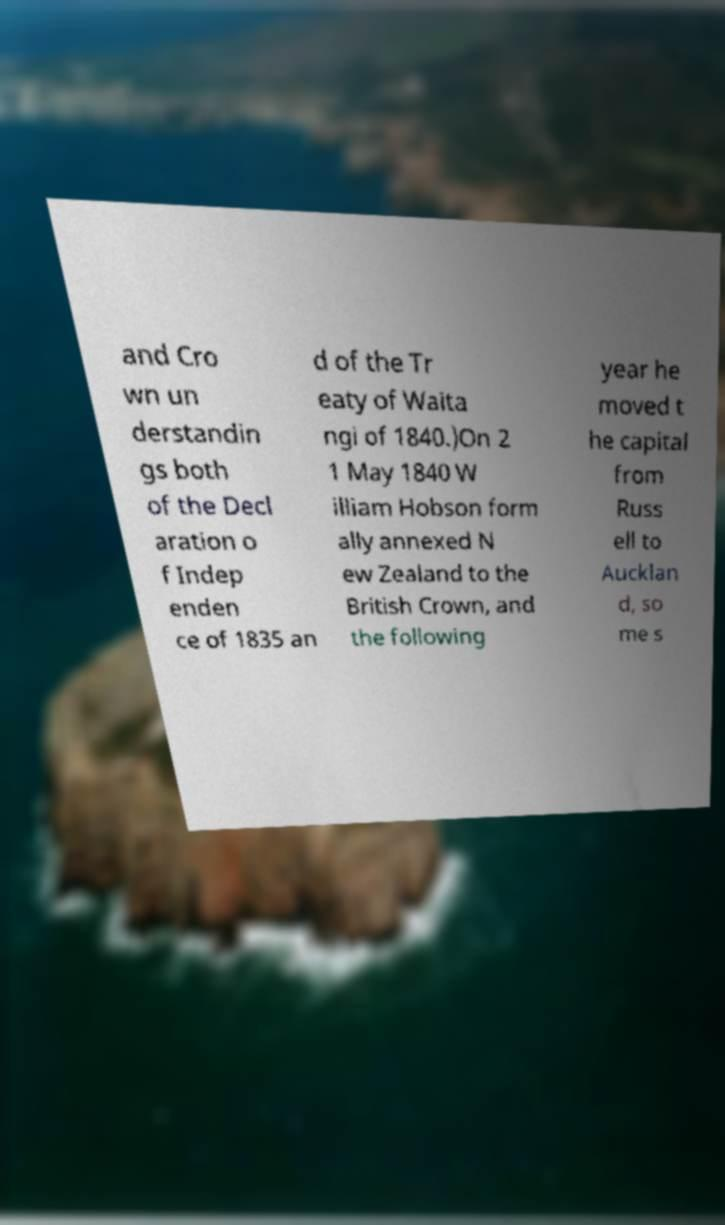Can you accurately transcribe the text from the provided image for me? and Cro wn un derstandin gs both of the Decl aration o f Indep enden ce of 1835 an d of the Tr eaty of Waita ngi of 1840.)On 2 1 May 1840 W illiam Hobson form ally annexed N ew Zealand to the British Crown, and the following year he moved t he capital from Russ ell to Aucklan d, so me s 